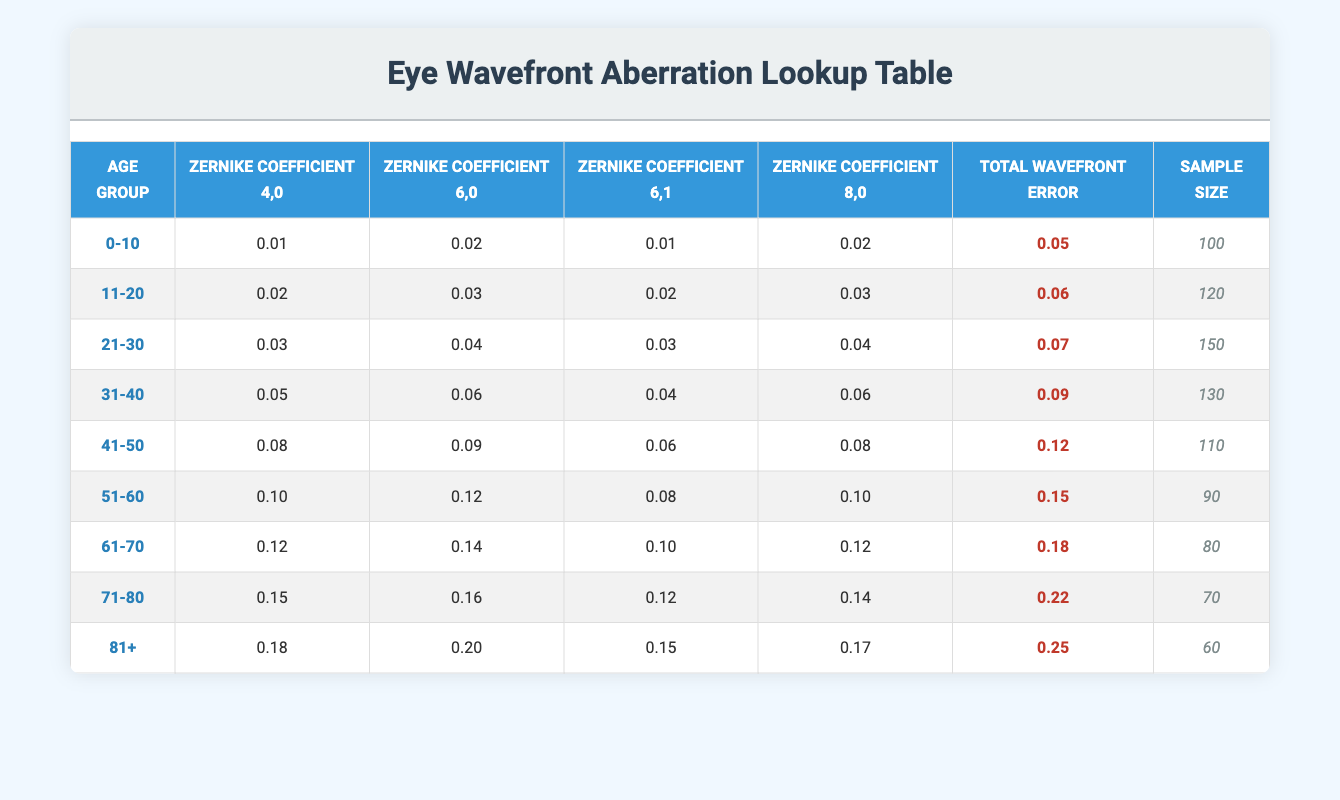What is the Total Wavefront Error for age group 31-40? The Total Wavefront Error for the age group 31-40 is listed in the table directly under that age group, which shows the value to be 0.09.
Answer: 0.09 Which age group has the highest Sample Size? By comparing the Sample Size values across all age groups, we can see that the age group 21-30 has the highest Sample Size of 150, as listed in the table.
Answer: 21-30 What is the average Total Wavefront Error for all age groups? To find the average Total Wavefront Error, we sum the Total Wavefront Error values across all age groups: (0.05 + 0.06 + 0.07 + 0.09 + 0.12 + 0.15 + 0.18 + 0.22 + 0.25) = 1.79. Then, we divide by the number of age groups, which is 9. Therefore, 1.79/9 = 0.199.
Answer: 0.199 Is the Zernike Coefficient 6,0 for age group 51-60 greater than the coefficient for age group 41-50? We can compare the Zernike Coefficient 6,0 values for both age groups: for age group 51-60, it is 0.12, while for age group 41-50, it is 0.09. Since 0.12 is greater than 0.09, the statement is true.
Answer: Yes What is the difference in Total Wavefront Error between the youngest (0-10) and oldest (81+) age groups? We calculate the Total Wavefront Error values for both age groups: the value for 0-10 is 0.05, and for 81+, it is 0.25. To find the difference, we subtract: 0.25 - 0.05 = 0.20.
Answer: 0.20 What is the Zernike Coefficient 4,0 value for the age group 71-80? The Zernike Coefficient 4,0 for the age group 71-80 is directly listed in the table under that age group, showing a value of 0.15.
Answer: 0.15 Does the age group 61-70 have a greater Total Wavefront Error than the age group 41-50? The Total Wavefront Error for age group 61-70 is 0.18 and for age group 41-50 it is 0.12. Since 0.18 is greater than 0.12, the statement is true.
Answer: Yes What are the Zernike Coefficient 6,1 values for the age groups 21-30 and 31-40, and which is greater? The Zernike Coefficient 6,1 value for age group 21-30 is 0.03, while for age group 31-40 it is 0.04. Comparing the two, we see that 0.04 (31-40) is greater than 0.03 (21-30).
Answer: 31-40 What is the total number of participants across all age groups? To find the total number of participants, we sum the Sample Size of all age groups: (100 + 120 + 150 + 130 + 110 + 90 + 80 + 70 + 60) = 1010.
Answer: 1010 